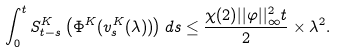<formula> <loc_0><loc_0><loc_500><loc_500>\int _ { 0 } ^ { t } S _ { t - s } ^ { K } \left ( \Phi ^ { K } ( v _ { s } ^ { K } ( \lambda ) ) \right ) d s \leq \frac { \chi ( 2 ) | | \varphi | | _ { \infty } ^ { 2 } t } { 2 } \times \lambda ^ { 2 } .</formula> 